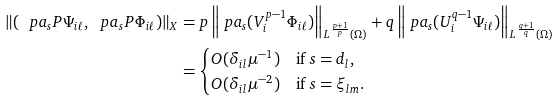<formula> <loc_0><loc_0><loc_500><loc_500>\| ( \ p a _ { s } P \Psi _ { i \ell } , \ p a _ { s } P \Phi _ { i \ell } ) \| _ { X } & = p \left \| \ p a _ { s } ( V _ { i } ^ { p - 1 } \Phi _ { i \ell } ) \right \| _ { L ^ { \frac { p + 1 } { p } } ( \Omega ) } + q \left \| \ p a _ { s } ( U _ { i } ^ { q - 1 } \Psi _ { i \ell } ) \right \| _ { L ^ { \frac { q + 1 } { q } } ( \Omega ) } \\ & = \begin{cases} O ( \delta _ { i l } \mu ^ { - 1 } ) & \text {if } s = d _ { l } , \\ O ( \delta _ { i l } \mu ^ { - 2 } ) & \text {if } s = \xi _ { l m } . \end{cases}</formula> 